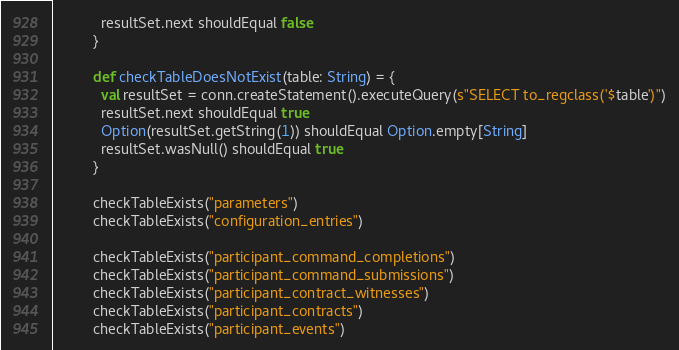Convert code to text. <code><loc_0><loc_0><loc_500><loc_500><_Scala_>            resultSet.next shouldEqual false
          }

          def checkTableDoesNotExist(table: String) = {
            val resultSet = conn.createStatement().executeQuery(s"SELECT to_regclass('$table')")
            resultSet.next shouldEqual true
            Option(resultSet.getString(1)) shouldEqual Option.empty[String]
            resultSet.wasNull() shouldEqual true
          }

          checkTableExists("parameters")
          checkTableExists("configuration_entries")

          checkTableExists("participant_command_completions")
          checkTableExists("participant_command_submissions")
          checkTableExists("participant_contract_witnesses")
          checkTableExists("participant_contracts")
          checkTableExists("participant_events")
</code> 